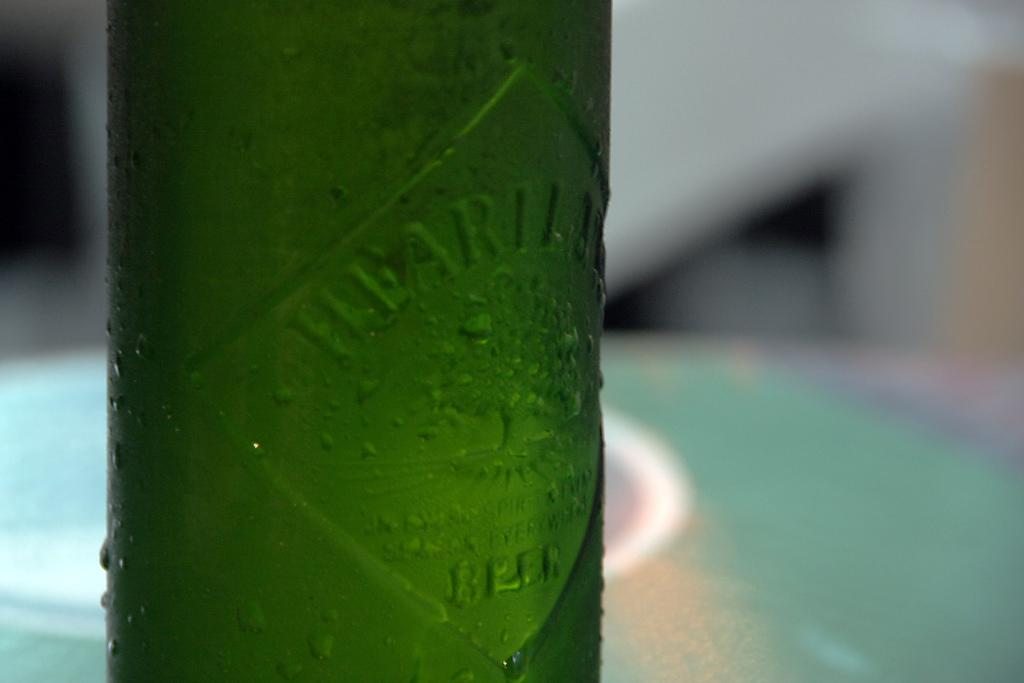What type of bottle is in the image? There is a green beer bottle in the image. Can you describe the appearance of the beer bottle? The beer bottle has water droplets on it. What can be observed about the background of the image? The background of the image is blurred. What word is written on the tree in the image? There is no tree or word present in the image. What type of floor can be seen beneath the beer bottle in the image? The image does not show the floor beneath the beer bottle; it only shows the beer bottle and the background. 